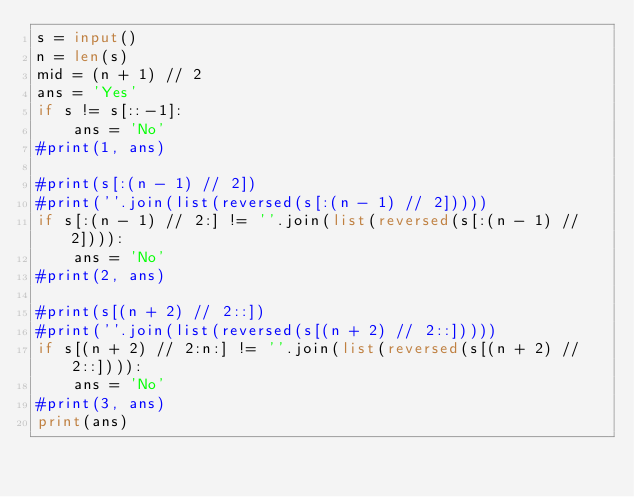<code> <loc_0><loc_0><loc_500><loc_500><_Python_>s = input()
n = len(s)
mid = (n + 1) // 2
ans = 'Yes'
if s != s[::-1]:
    ans = 'No'
#print(1, ans)

#print(s[:(n - 1) // 2])
#print(''.join(list(reversed(s[:(n - 1) // 2]))))
if s[:(n - 1) // 2:] != ''.join(list(reversed(s[:(n - 1) // 2]))):
    ans = 'No'
#print(2, ans)

#print(s[(n + 2) // 2::])
#print(''.join(list(reversed(s[(n + 2) // 2::]))))
if s[(n + 2) // 2:n:] != ''.join(list(reversed(s[(n + 2) // 2::]))):
    ans = 'No'
#print(3, ans)
print(ans)</code> 